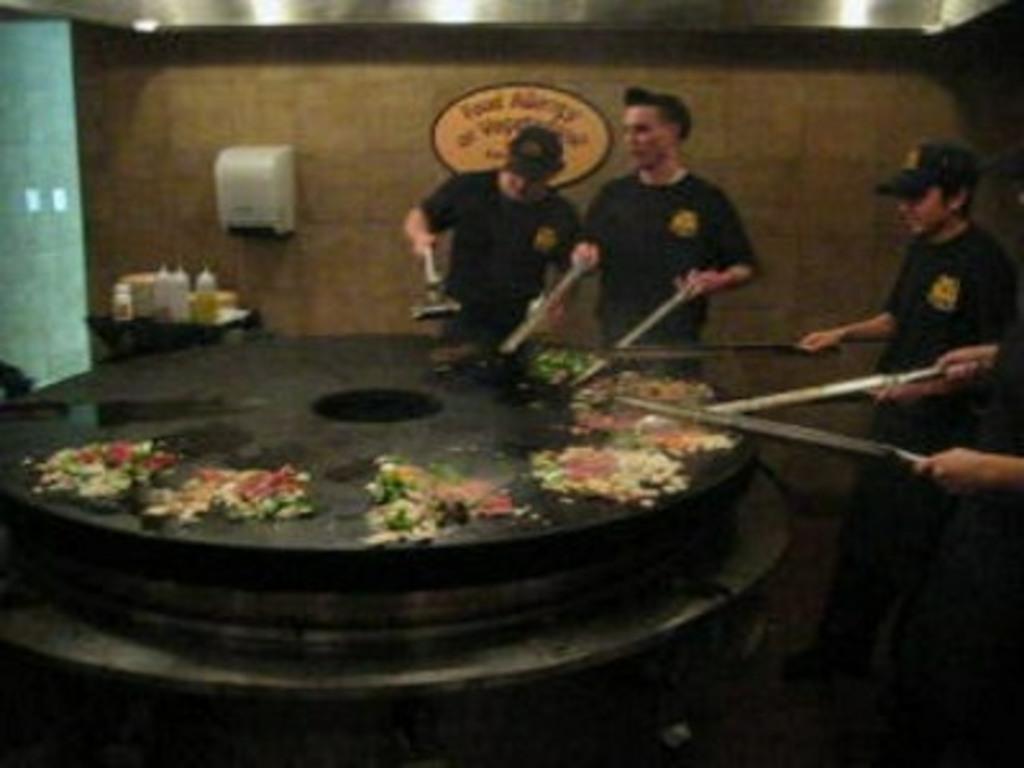In one or two sentences, can you explain what this image depicts? In this image I can see few people are holding something. In front I can see a food on the black color surface. I can see few bottles and few objects on the table. I can see the white color object attached to the brown wall. 